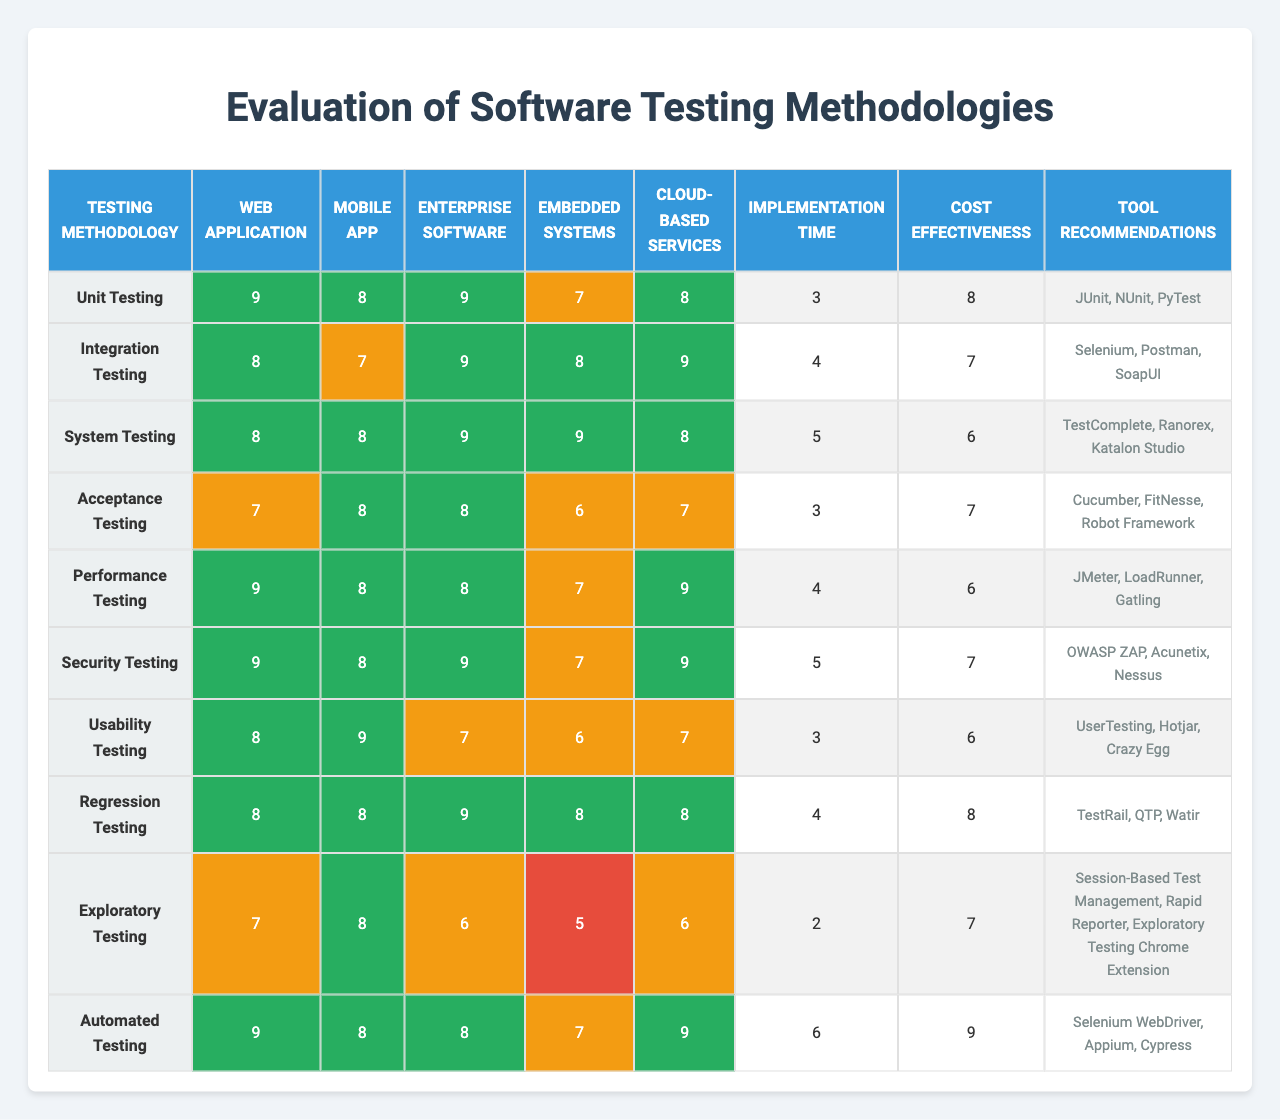What is the effectiveness rating of Unit Testing for Cloud-based Services? The table shows that the effectiveness rating of Unit Testing for Cloud-based Services is 8.
Answer: 8 Which testing methodology has the highest effectiveness rating for Mobile Apps? According to the table, Usability Testing has the highest effectiveness rating for Mobile Apps, with a score of 9.
Answer: Usability Testing What is the average effectiveness rating of System Testing across all project types? To find the average, we add the ratings for System Testing (8 + 8 + 9 + 9 + 8), which totals 42. Then, we divide by the number of project types (5): 42/5 = 8.4.
Answer: 8.4 Is Security Testing considered more effective for Web Applications than for Embedded Systems? The effectiveness rating for Security Testing in Web Applications is 9, while for Embedded Systems, it is 7. Since 9 is greater than 7, Security Testing is more effective for Web Applications.
Answer: Yes Which testing methodology has the lowest cost-effectiveness rating and what is that rating? The methodology with the lowest cost-effectiveness rating is System Testing, which has a rating of 6.
Answer: 6 How much longer does Automated Testing take to implement compared to Exploratory Testing? The implementation time for Automated Testing is 6, and for Exploratory Testing, it is 2. The difference in time is 6 - 2 = 4.
Answer: 4 Which testing methodology has the highest cost-effectiveness rating? The table shows that Automated Testing has the highest cost-effectiveness rating of 9.
Answer: Automated Testing What is the effectiveness rating of Integration Testing for Embedded Systems? The table indicates that the effectiveness rating of Integration Testing for Embedded Systems is 8.
Answer: 8 Which two project types received the same effectiveness rating for Regression Testing? For Regression Testing, both Enterprise Software and Cloud-based Services received the same effectiveness rating of 9.
Answer: Enterprise Software and Cloud-based Services Which testing methodology has a higher effectiveness rating for Web Applications: Acceptance Testing or Performance Testing? Acceptance Testing has an effectiveness rating of 7 for Web Applications, while Performance Testing has a rating of 9. Hence, Performance Testing is rated higher.
Answer: Performance Testing 